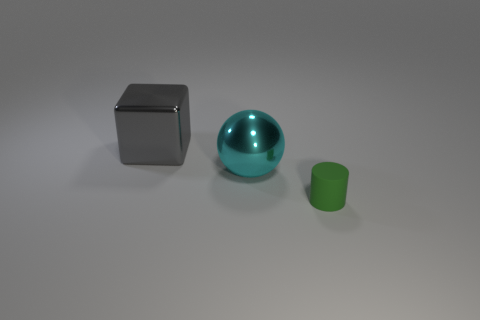Are there any other things that have the same size as the gray shiny thing?
Make the answer very short. Yes. Are there more green matte cylinders that are behind the rubber object than tiny green objects that are right of the big gray metallic thing?
Give a very brief answer. No. What color is the object on the left side of the large metal object on the right side of the big gray metallic thing that is to the left of the sphere?
Make the answer very short. Gray. There is a thing on the right side of the big sphere; is it the same color as the cube?
Your response must be concise. No. What number of things are either matte cylinders or cyan metal balls?
Provide a short and direct response. 2. How many objects are either small green rubber spheres or shiny objects that are right of the large gray shiny cube?
Your answer should be compact. 1. Is the material of the large gray object the same as the small green object?
Offer a very short reply. No. What number of other objects are there of the same material as the green cylinder?
Your answer should be compact. 0. Are there more green rubber things than large red metallic spheres?
Offer a very short reply. Yes. Do the cyan shiny object that is in front of the large metal cube and the matte thing have the same shape?
Ensure brevity in your answer.  No. 